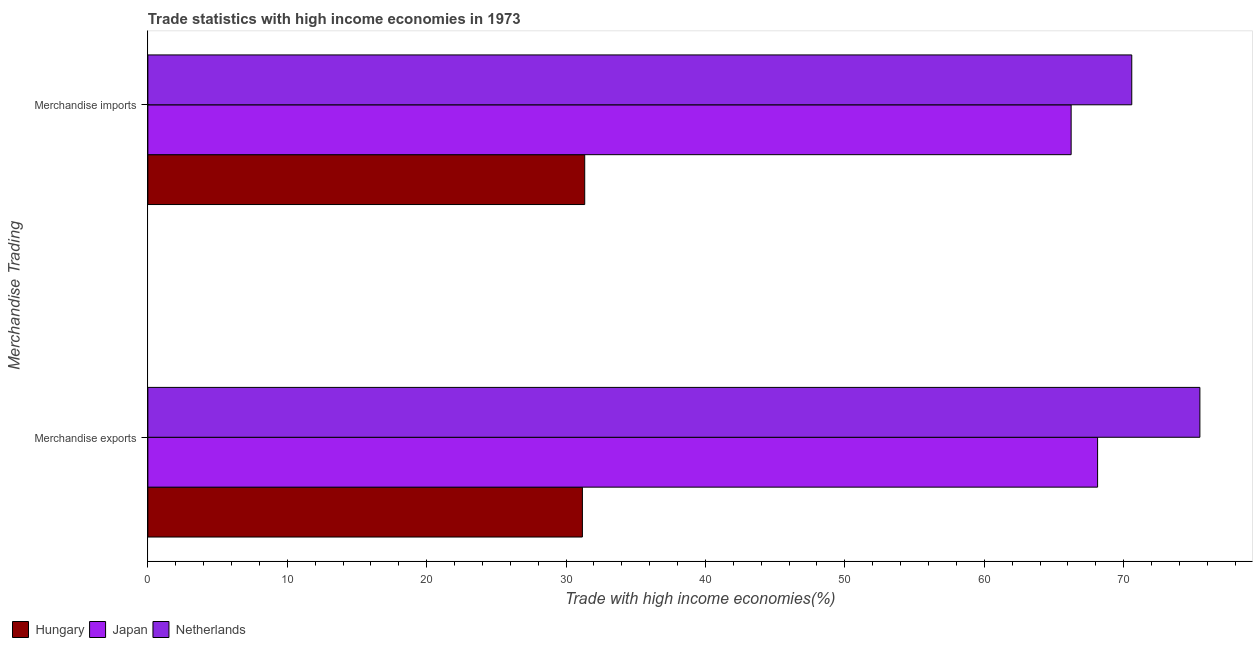Are the number of bars on each tick of the Y-axis equal?
Provide a short and direct response. Yes. How many bars are there on the 2nd tick from the bottom?
Your answer should be compact. 3. What is the merchandise imports in Hungary?
Your answer should be very brief. 31.34. Across all countries, what is the maximum merchandise exports?
Offer a very short reply. 75.47. Across all countries, what is the minimum merchandise exports?
Make the answer very short. 31.17. In which country was the merchandise exports maximum?
Keep it short and to the point. Netherlands. In which country was the merchandise imports minimum?
Your answer should be compact. Hungary. What is the total merchandise imports in the graph?
Your answer should be compact. 168.15. What is the difference between the merchandise exports in Hungary and that in Japan?
Keep it short and to the point. -36.96. What is the difference between the merchandise exports in Hungary and the merchandise imports in Netherlands?
Give a very brief answer. -39.41. What is the average merchandise imports per country?
Give a very brief answer. 56.05. What is the difference between the merchandise imports and merchandise exports in Japan?
Give a very brief answer. -1.9. In how many countries, is the merchandise imports greater than 6 %?
Your answer should be very brief. 3. What is the ratio of the merchandise imports in Hungary to that in Japan?
Give a very brief answer. 0.47. In how many countries, is the merchandise exports greater than the average merchandise exports taken over all countries?
Ensure brevity in your answer.  2. What does the 2nd bar from the bottom in Merchandise imports represents?
Offer a very short reply. Japan. How many countries are there in the graph?
Make the answer very short. 3. Does the graph contain any zero values?
Your response must be concise. No. Does the graph contain grids?
Your answer should be very brief. No. What is the title of the graph?
Provide a succinct answer. Trade statistics with high income economies in 1973. What is the label or title of the X-axis?
Ensure brevity in your answer.  Trade with high income economies(%). What is the label or title of the Y-axis?
Ensure brevity in your answer.  Merchandise Trading. What is the Trade with high income economies(%) in Hungary in Merchandise exports?
Ensure brevity in your answer.  31.17. What is the Trade with high income economies(%) in Japan in Merchandise exports?
Give a very brief answer. 68.13. What is the Trade with high income economies(%) of Netherlands in Merchandise exports?
Keep it short and to the point. 75.47. What is the Trade with high income economies(%) of Hungary in Merchandise imports?
Offer a very short reply. 31.34. What is the Trade with high income economies(%) in Japan in Merchandise imports?
Offer a very short reply. 66.23. What is the Trade with high income economies(%) of Netherlands in Merchandise imports?
Ensure brevity in your answer.  70.58. Across all Merchandise Trading, what is the maximum Trade with high income economies(%) in Hungary?
Give a very brief answer. 31.34. Across all Merchandise Trading, what is the maximum Trade with high income economies(%) in Japan?
Make the answer very short. 68.13. Across all Merchandise Trading, what is the maximum Trade with high income economies(%) in Netherlands?
Make the answer very short. 75.47. Across all Merchandise Trading, what is the minimum Trade with high income economies(%) of Hungary?
Provide a succinct answer. 31.17. Across all Merchandise Trading, what is the minimum Trade with high income economies(%) of Japan?
Keep it short and to the point. 66.23. Across all Merchandise Trading, what is the minimum Trade with high income economies(%) of Netherlands?
Your response must be concise. 70.58. What is the total Trade with high income economies(%) of Hungary in the graph?
Your response must be concise. 62.51. What is the total Trade with high income economies(%) in Japan in the graph?
Provide a short and direct response. 134.36. What is the total Trade with high income economies(%) in Netherlands in the graph?
Ensure brevity in your answer.  146.05. What is the difference between the Trade with high income economies(%) in Hungary in Merchandise exports and that in Merchandise imports?
Your answer should be very brief. -0.17. What is the difference between the Trade with high income economies(%) of Japan in Merchandise exports and that in Merchandise imports?
Your answer should be compact. 1.9. What is the difference between the Trade with high income economies(%) of Netherlands in Merchandise exports and that in Merchandise imports?
Ensure brevity in your answer.  4.89. What is the difference between the Trade with high income economies(%) of Hungary in Merchandise exports and the Trade with high income economies(%) of Japan in Merchandise imports?
Offer a terse response. -35.06. What is the difference between the Trade with high income economies(%) in Hungary in Merchandise exports and the Trade with high income economies(%) in Netherlands in Merchandise imports?
Ensure brevity in your answer.  -39.41. What is the difference between the Trade with high income economies(%) of Japan in Merchandise exports and the Trade with high income economies(%) of Netherlands in Merchandise imports?
Give a very brief answer. -2.45. What is the average Trade with high income economies(%) of Hungary per Merchandise Trading?
Your answer should be very brief. 31.26. What is the average Trade with high income economies(%) of Japan per Merchandise Trading?
Ensure brevity in your answer.  67.18. What is the average Trade with high income economies(%) in Netherlands per Merchandise Trading?
Your answer should be compact. 73.03. What is the difference between the Trade with high income economies(%) of Hungary and Trade with high income economies(%) of Japan in Merchandise exports?
Provide a short and direct response. -36.96. What is the difference between the Trade with high income economies(%) of Hungary and Trade with high income economies(%) of Netherlands in Merchandise exports?
Offer a very short reply. -44.3. What is the difference between the Trade with high income economies(%) in Japan and Trade with high income economies(%) in Netherlands in Merchandise exports?
Your answer should be very brief. -7.34. What is the difference between the Trade with high income economies(%) in Hungary and Trade with high income economies(%) in Japan in Merchandise imports?
Ensure brevity in your answer.  -34.89. What is the difference between the Trade with high income economies(%) in Hungary and Trade with high income economies(%) in Netherlands in Merchandise imports?
Your answer should be compact. -39.24. What is the difference between the Trade with high income economies(%) in Japan and Trade with high income economies(%) in Netherlands in Merchandise imports?
Provide a short and direct response. -4.35. What is the ratio of the Trade with high income economies(%) in Japan in Merchandise exports to that in Merchandise imports?
Keep it short and to the point. 1.03. What is the ratio of the Trade with high income economies(%) in Netherlands in Merchandise exports to that in Merchandise imports?
Offer a very short reply. 1.07. What is the difference between the highest and the second highest Trade with high income economies(%) of Hungary?
Make the answer very short. 0.17. What is the difference between the highest and the second highest Trade with high income economies(%) in Japan?
Give a very brief answer. 1.9. What is the difference between the highest and the second highest Trade with high income economies(%) in Netherlands?
Your answer should be compact. 4.89. What is the difference between the highest and the lowest Trade with high income economies(%) of Hungary?
Your answer should be compact. 0.17. What is the difference between the highest and the lowest Trade with high income economies(%) in Japan?
Your answer should be compact. 1.9. What is the difference between the highest and the lowest Trade with high income economies(%) of Netherlands?
Offer a very short reply. 4.89. 